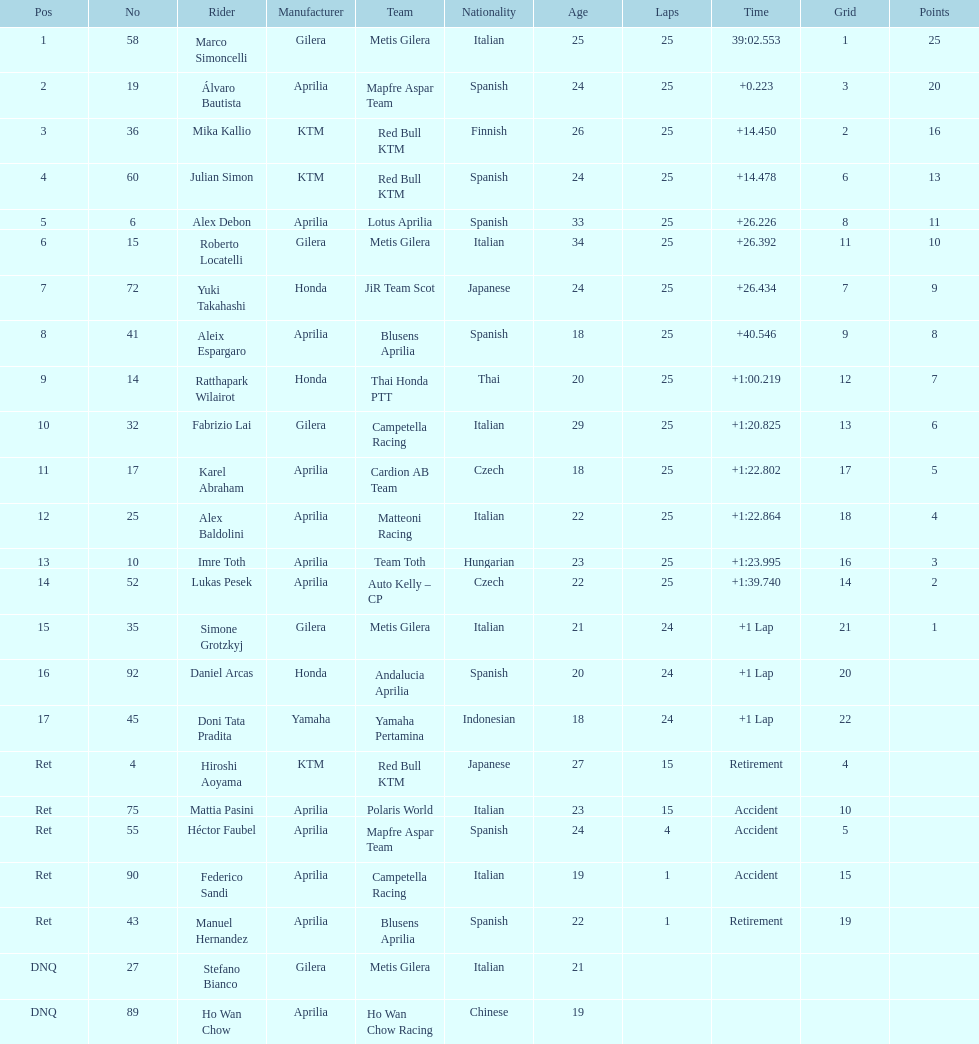In which nation can the greatest quantity of riders be found? Italy. 